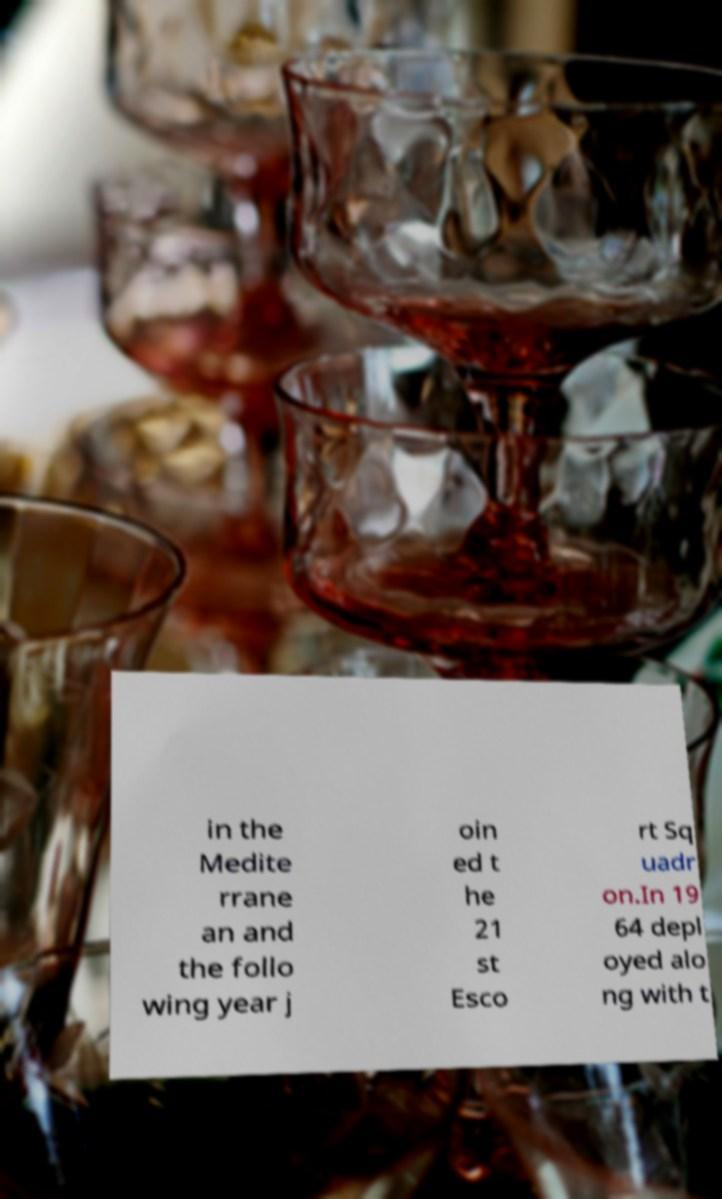What messages or text are displayed in this image? I need them in a readable, typed format. in the Medite rrane an and the follo wing year j oin ed t he 21 st Esco rt Sq uadr on.In 19 64 depl oyed alo ng with t 